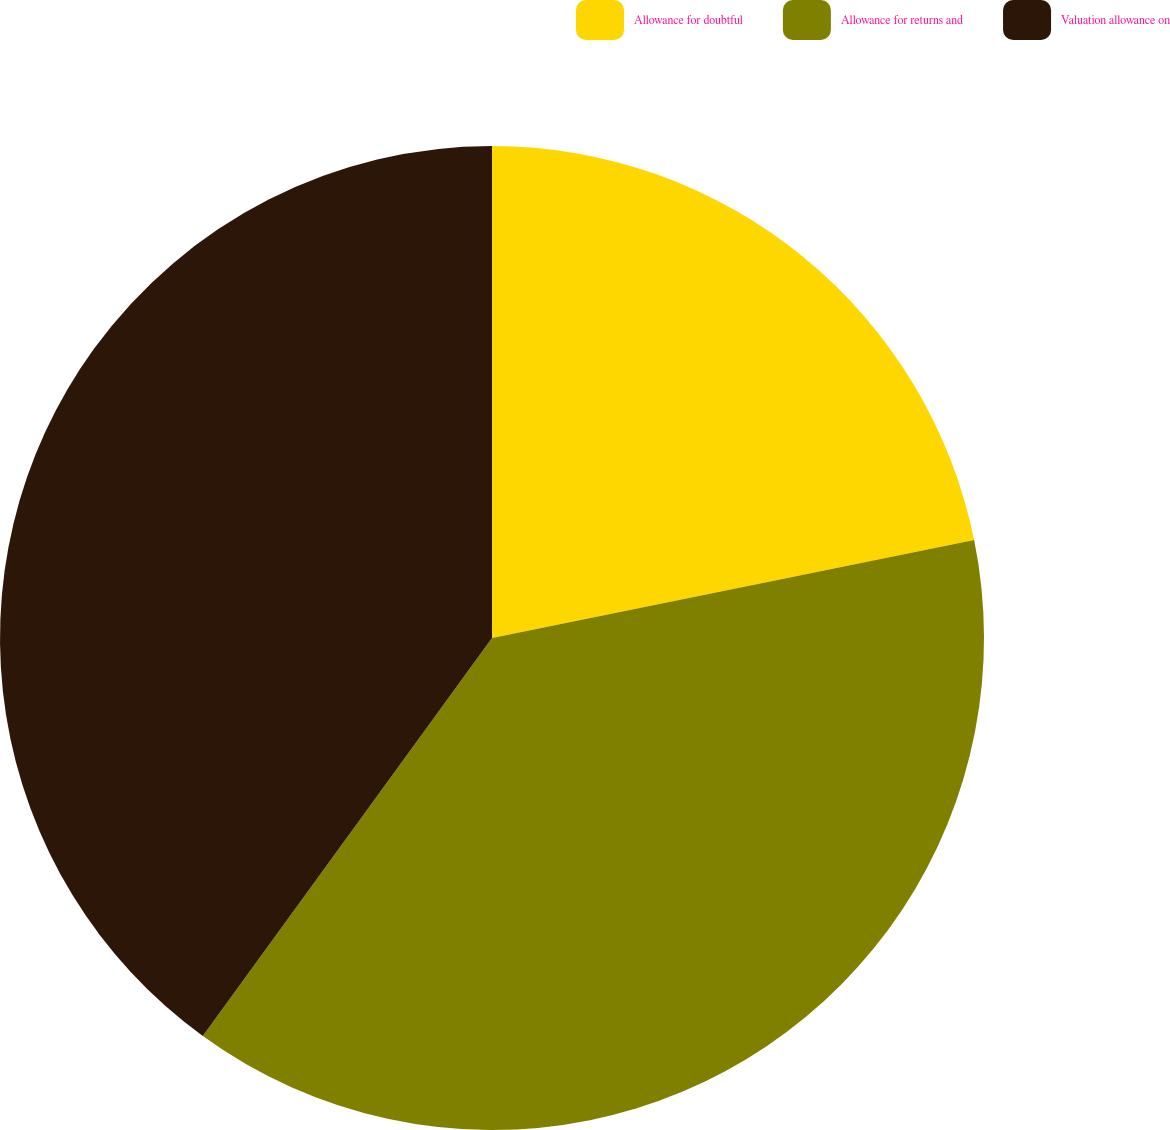Convert chart to OTSL. <chart><loc_0><loc_0><loc_500><loc_500><pie_chart><fcel>Allowance for doubtful<fcel>Allowance for returns and<fcel>Valuation allowance on<nl><fcel>21.81%<fcel>38.19%<fcel>40.0%<nl></chart> 